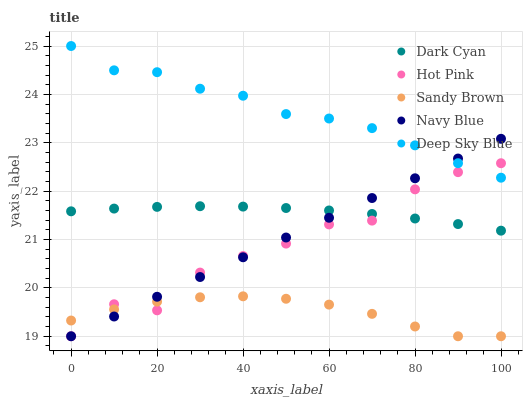Does Sandy Brown have the minimum area under the curve?
Answer yes or no. Yes. Does Deep Sky Blue have the maximum area under the curve?
Answer yes or no. Yes. Does Navy Blue have the minimum area under the curve?
Answer yes or no. No. Does Navy Blue have the maximum area under the curve?
Answer yes or no. No. Is Navy Blue the smoothest?
Answer yes or no. Yes. Is Hot Pink the roughest?
Answer yes or no. Yes. Is Hot Pink the smoothest?
Answer yes or no. No. Is Navy Blue the roughest?
Answer yes or no. No. Does Navy Blue have the lowest value?
Answer yes or no. Yes. Does Deep Sky Blue have the lowest value?
Answer yes or no. No. Does Deep Sky Blue have the highest value?
Answer yes or no. Yes. Does Navy Blue have the highest value?
Answer yes or no. No. Is Sandy Brown less than Dark Cyan?
Answer yes or no. Yes. Is Dark Cyan greater than Sandy Brown?
Answer yes or no. Yes. Does Hot Pink intersect Deep Sky Blue?
Answer yes or no. Yes. Is Hot Pink less than Deep Sky Blue?
Answer yes or no. No. Is Hot Pink greater than Deep Sky Blue?
Answer yes or no. No. Does Sandy Brown intersect Dark Cyan?
Answer yes or no. No. 